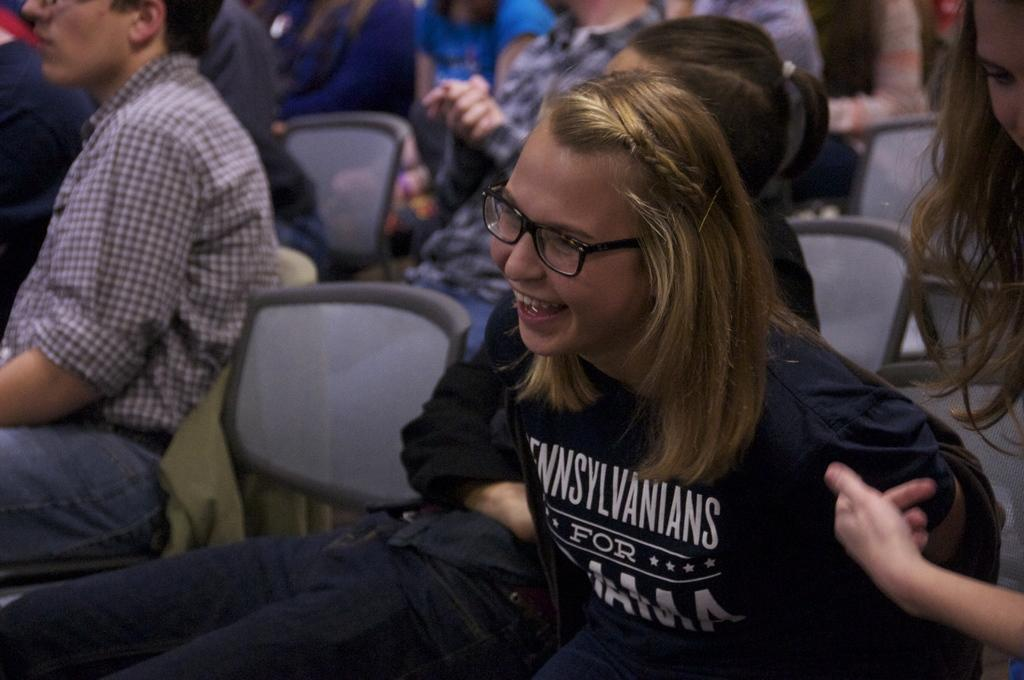What is the expression of the person in the image? The person in the image has a smile. Where is the person sitting in the image? The person is sitting on a chair on the right side. Can you describe the people in the background of the image? There are a few people sitting on chairs in the background. What type of harmony can be heard in the image? There is no audible sound or music in the image, so it is not possible to determine the type of harmony. 